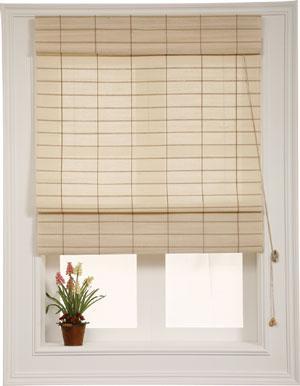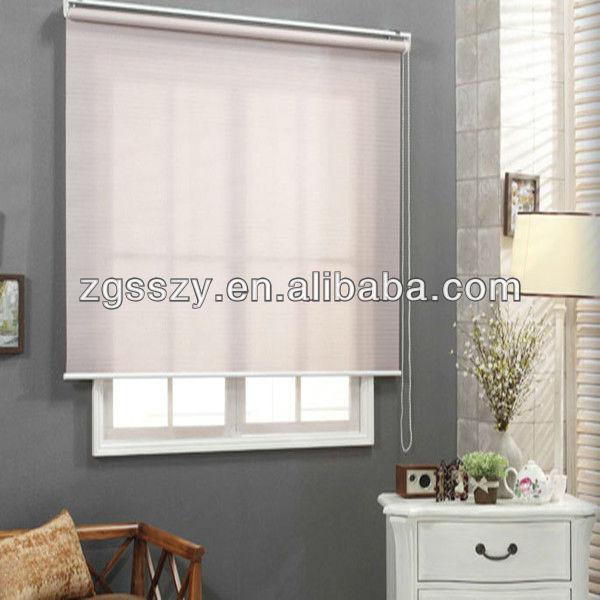The first image is the image on the left, the second image is the image on the right. Examine the images to the left and right. Is the description "In the image to the left, some chairs are visible in front of the window." accurate? Answer yes or no. No. 